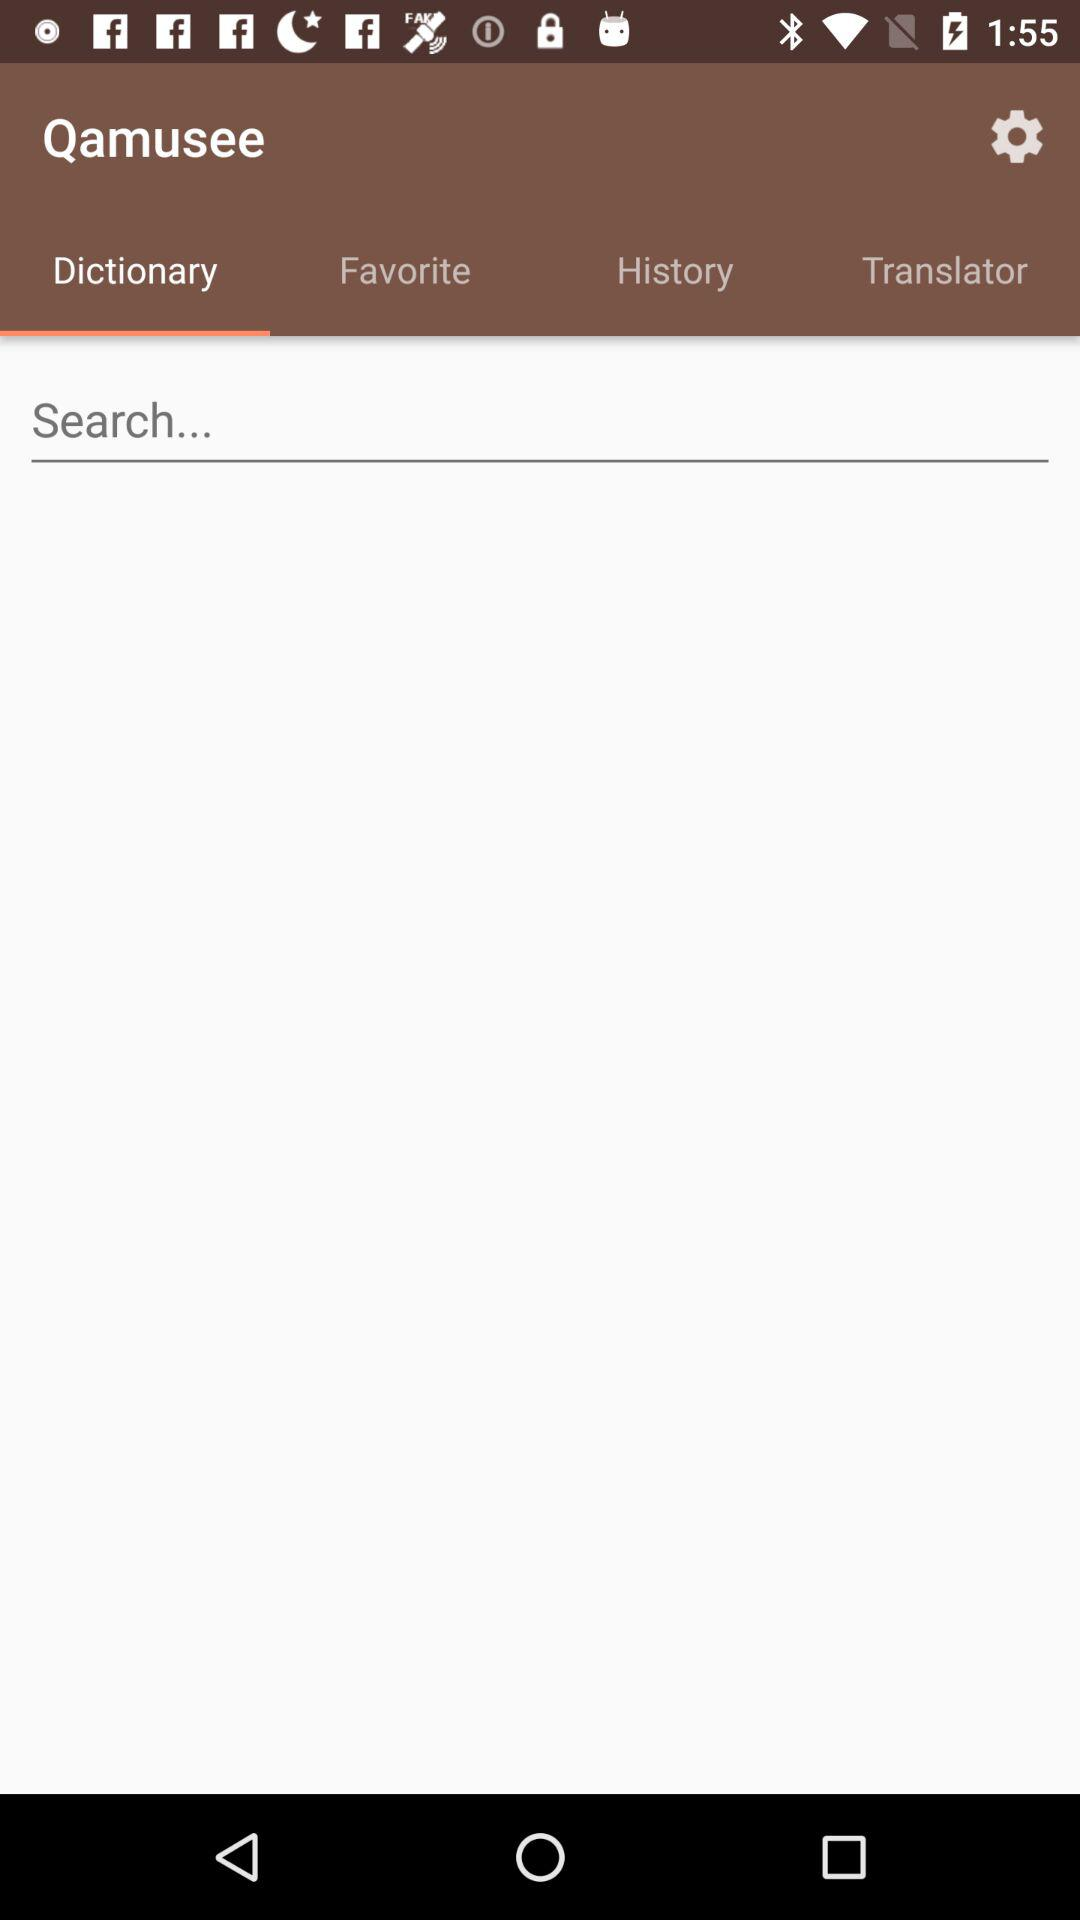Which option is selected in the "Qamusee" app? The selected option is "Dictionary". 